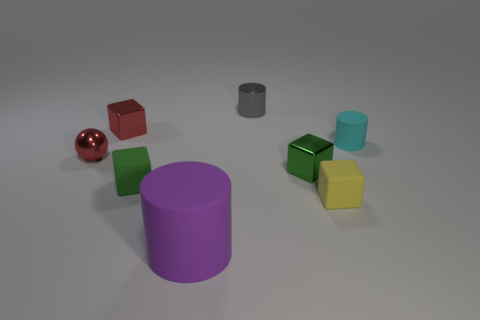What number of metallic objects are behind the tiny green shiny cube and in front of the small red block?
Make the answer very short. 1. There is a green block that is behind the tiny green rubber block; what is it made of?
Offer a terse response. Metal. The green block that is made of the same material as the small gray cylinder is what size?
Offer a terse response. Small. There is a matte cylinder that is in front of the shiny sphere; is its size the same as the matte cylinder that is behind the green metallic cube?
Offer a terse response. No. There is a cyan cylinder that is the same size as the red shiny block; what is it made of?
Your response must be concise. Rubber. There is a cylinder that is both in front of the gray metallic object and on the right side of the purple thing; what material is it?
Provide a short and direct response. Rubber. Are any small rubber cylinders visible?
Provide a succinct answer. Yes. There is a big rubber cylinder; does it have the same color as the shiny thing that is in front of the red shiny sphere?
Your answer should be very brief. No. What material is the block that is the same color as the metallic ball?
Give a very brief answer. Metal. Is there anything else that is the same shape as the tiny gray object?
Ensure brevity in your answer.  Yes. 